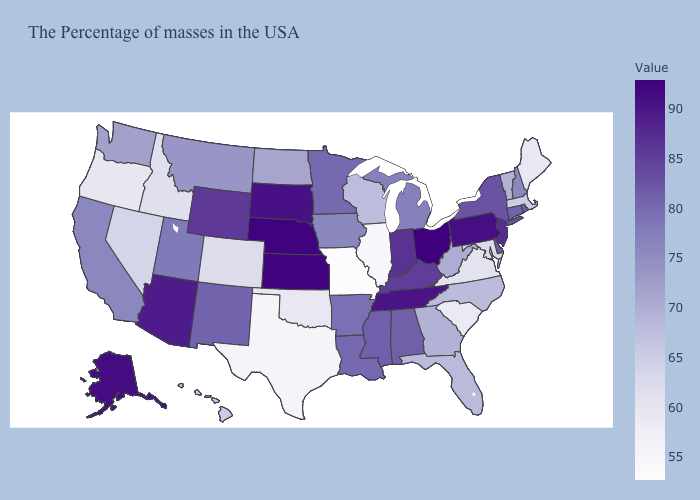Does Missouri have the lowest value in the USA?
Short answer required. Yes. Does New Hampshire have the lowest value in the Northeast?
Short answer required. No. Does Nevada have a higher value than South Dakota?
Be succinct. No. Among the states that border Kansas , does Nebraska have the highest value?
Answer briefly. Yes. 